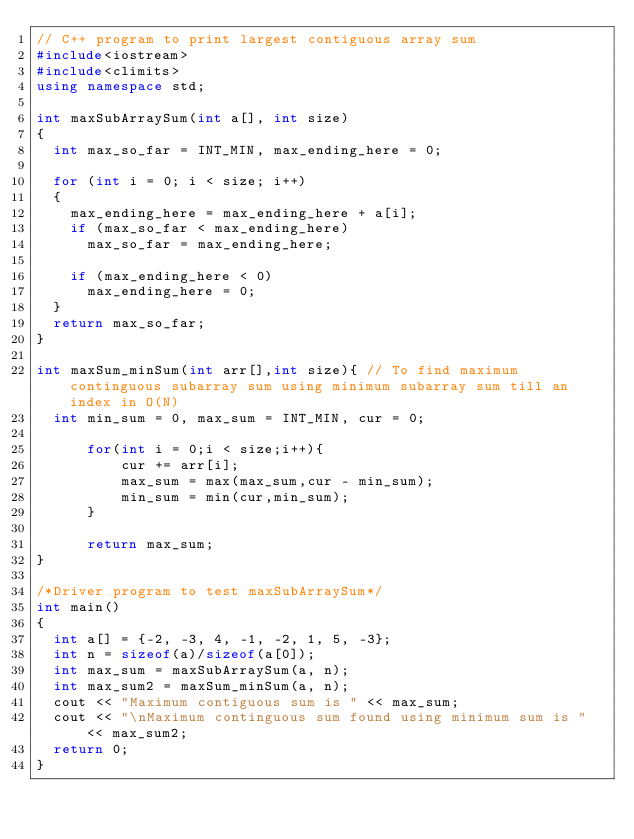Convert code to text. <code><loc_0><loc_0><loc_500><loc_500><_C++_>// C++ program to print largest contiguous array sum 
#include<iostream> 
#include<climits> 
using namespace std; 

int maxSubArraySum(int a[], int size) 
{ 
	int max_so_far = INT_MIN, max_ending_here = 0; 

	for (int i = 0; i < size; i++) 
	{ 
		max_ending_here = max_ending_here + a[i]; 
		if (max_so_far < max_ending_here) 
			max_so_far = max_ending_here; 

		if (max_ending_here < 0) 
			max_ending_here = 0; 
	} 
	return max_so_far; 
} 

int maxSum_minSum(int arr[],int size){ // To find maximum continguous subarray sum using minimum subarray sum till an index in O(N)
	int min_sum = 0, max_sum = INT_MIN, cur = 0;
	
    	for(int i = 0;i < size;i++){
        	cur += arr[i];
        	max_sum = max(max_sum,cur - min_sum);
        	min_sum = min(cur,min_sum);
    	}
	
    	return max_sum;
}

/*Driver program to test maxSubArraySum*/
int main() 
{ 
	int a[] = {-2, -3, 4, -1, -2, 1, 5, -3}; 
	int n = sizeof(a)/sizeof(a[0]); 
	int max_sum = maxSubArraySum(a, n); 
	int max_sum2 = maxSum_minSum(a, n);
	cout << "Maximum contiguous sum is " << max_sum;
	cout << "\nMaximum continguous sum found using minimum sum is " << max_sum2;
	return 0; 
} 
</code> 